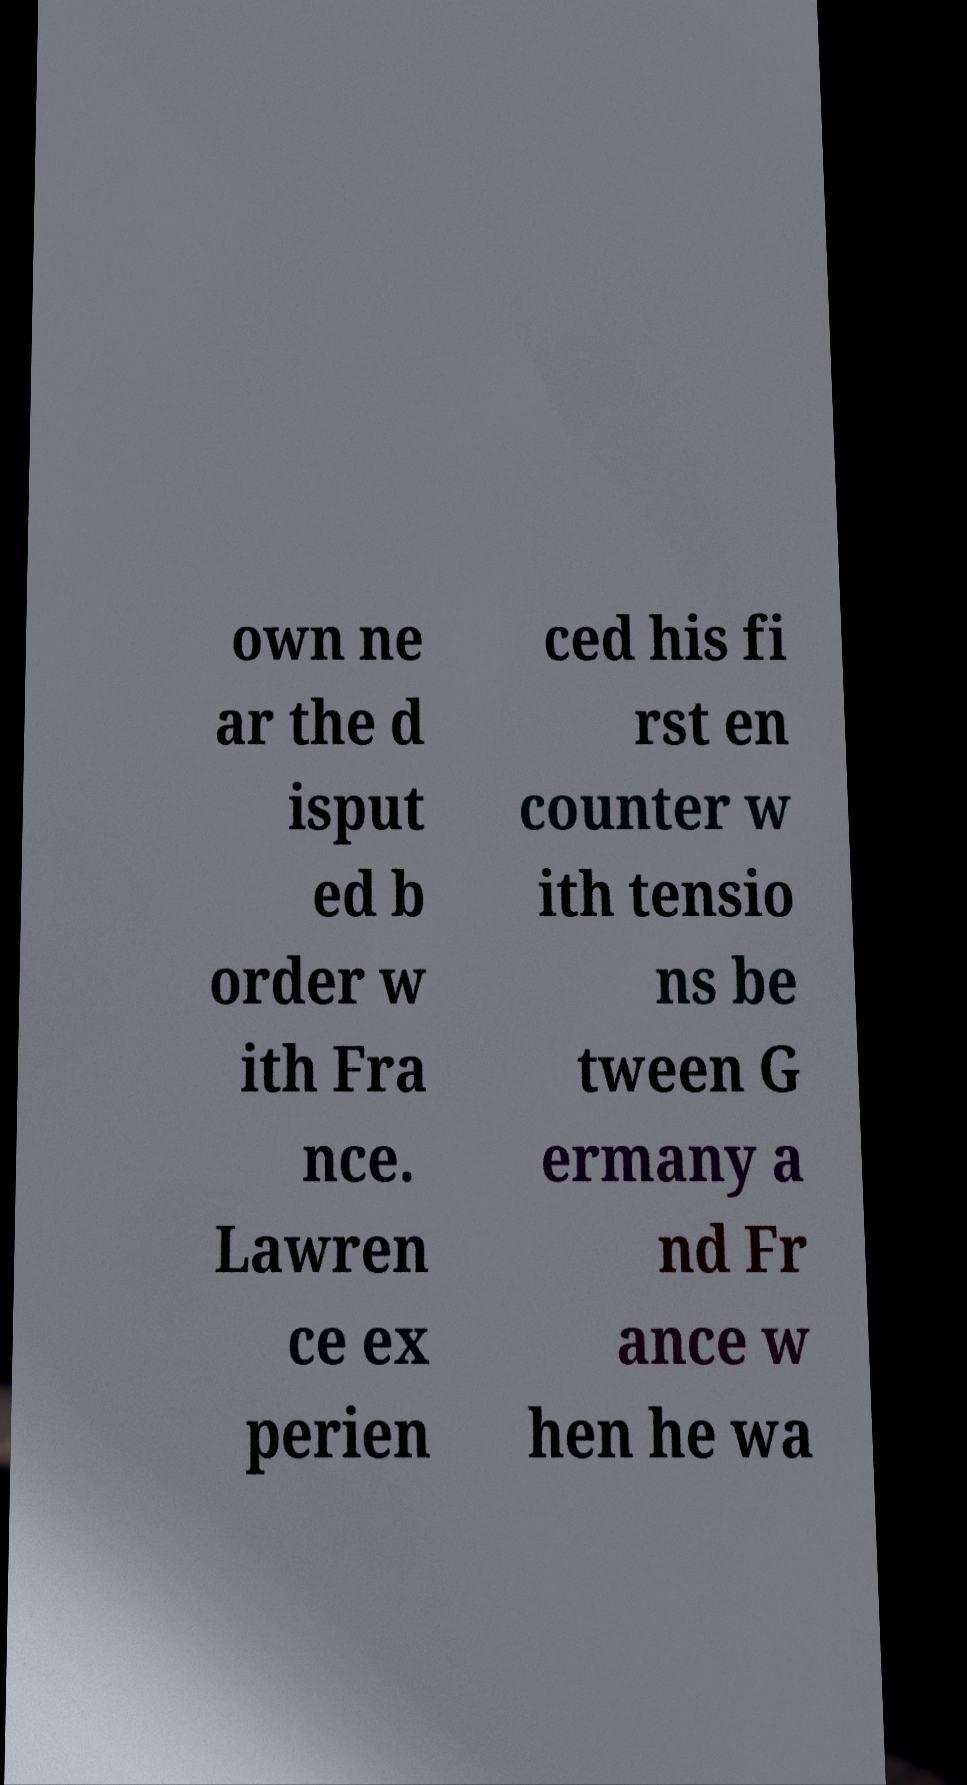What messages or text are displayed in this image? I need them in a readable, typed format. own ne ar the d isput ed b order w ith Fra nce. Lawren ce ex perien ced his fi rst en counter w ith tensio ns be tween G ermany a nd Fr ance w hen he wa 